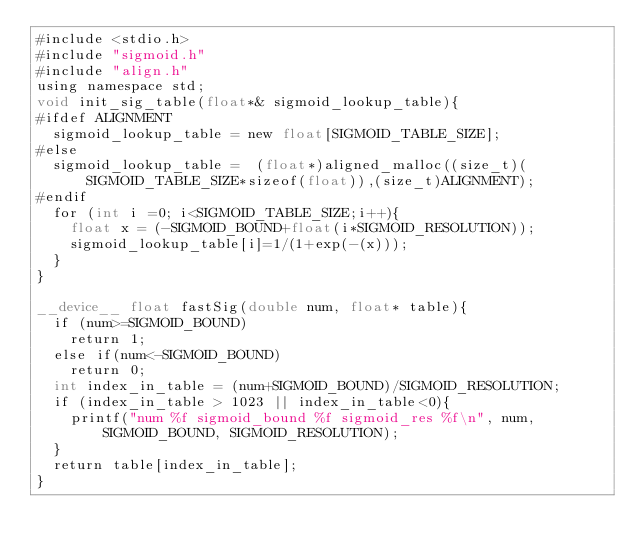Convert code to text. <code><loc_0><loc_0><loc_500><loc_500><_Cuda_>#include <stdio.h>
#include "sigmoid.h"
#include "align.h"
using namespace std;
void init_sig_table(float*& sigmoid_lookup_table){
#ifdef ALIGNMENT
  sigmoid_lookup_table = new float[SIGMOID_TABLE_SIZE];
#else
  sigmoid_lookup_table =  (float*)aligned_malloc((size_t)(SIGMOID_TABLE_SIZE*sizeof(float)),(size_t)ALIGNMENT);
#endif
  for (int i =0; i<SIGMOID_TABLE_SIZE;i++){
    float x = (-SIGMOID_BOUND+float(i*SIGMOID_RESOLUTION));
    sigmoid_lookup_table[i]=1/(1+exp(-(x)));
  }
}

__device__ float fastSig(double num, float* table){
  if (num>=SIGMOID_BOUND)
    return 1;
  else if(num<-SIGMOID_BOUND)
    return 0;
  int index_in_table = (num+SIGMOID_BOUND)/SIGMOID_RESOLUTION;
  if (index_in_table > 1023 || index_in_table<0){
    printf("num %f sigmoid_bound %f sigmoid_res %f\n", num, SIGMOID_BOUND, SIGMOID_RESOLUTION);
  }
  return table[index_in_table];
}
</code> 